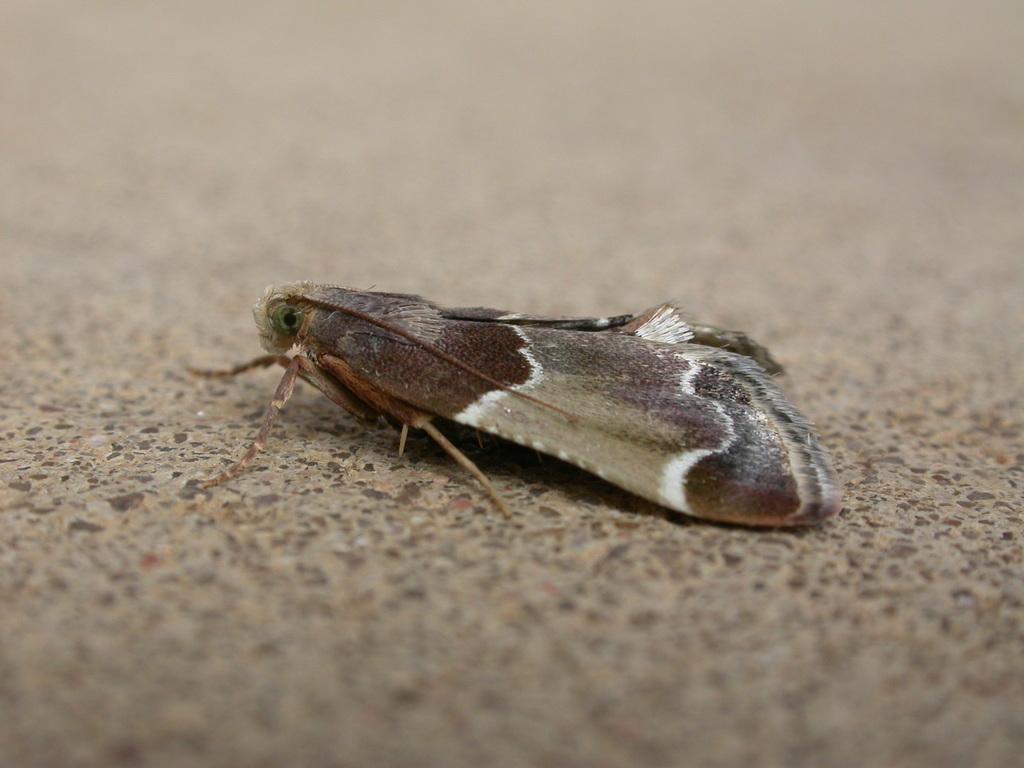How would you summarize this image in a sentence or two? In this image we can see an insect on the surface. 